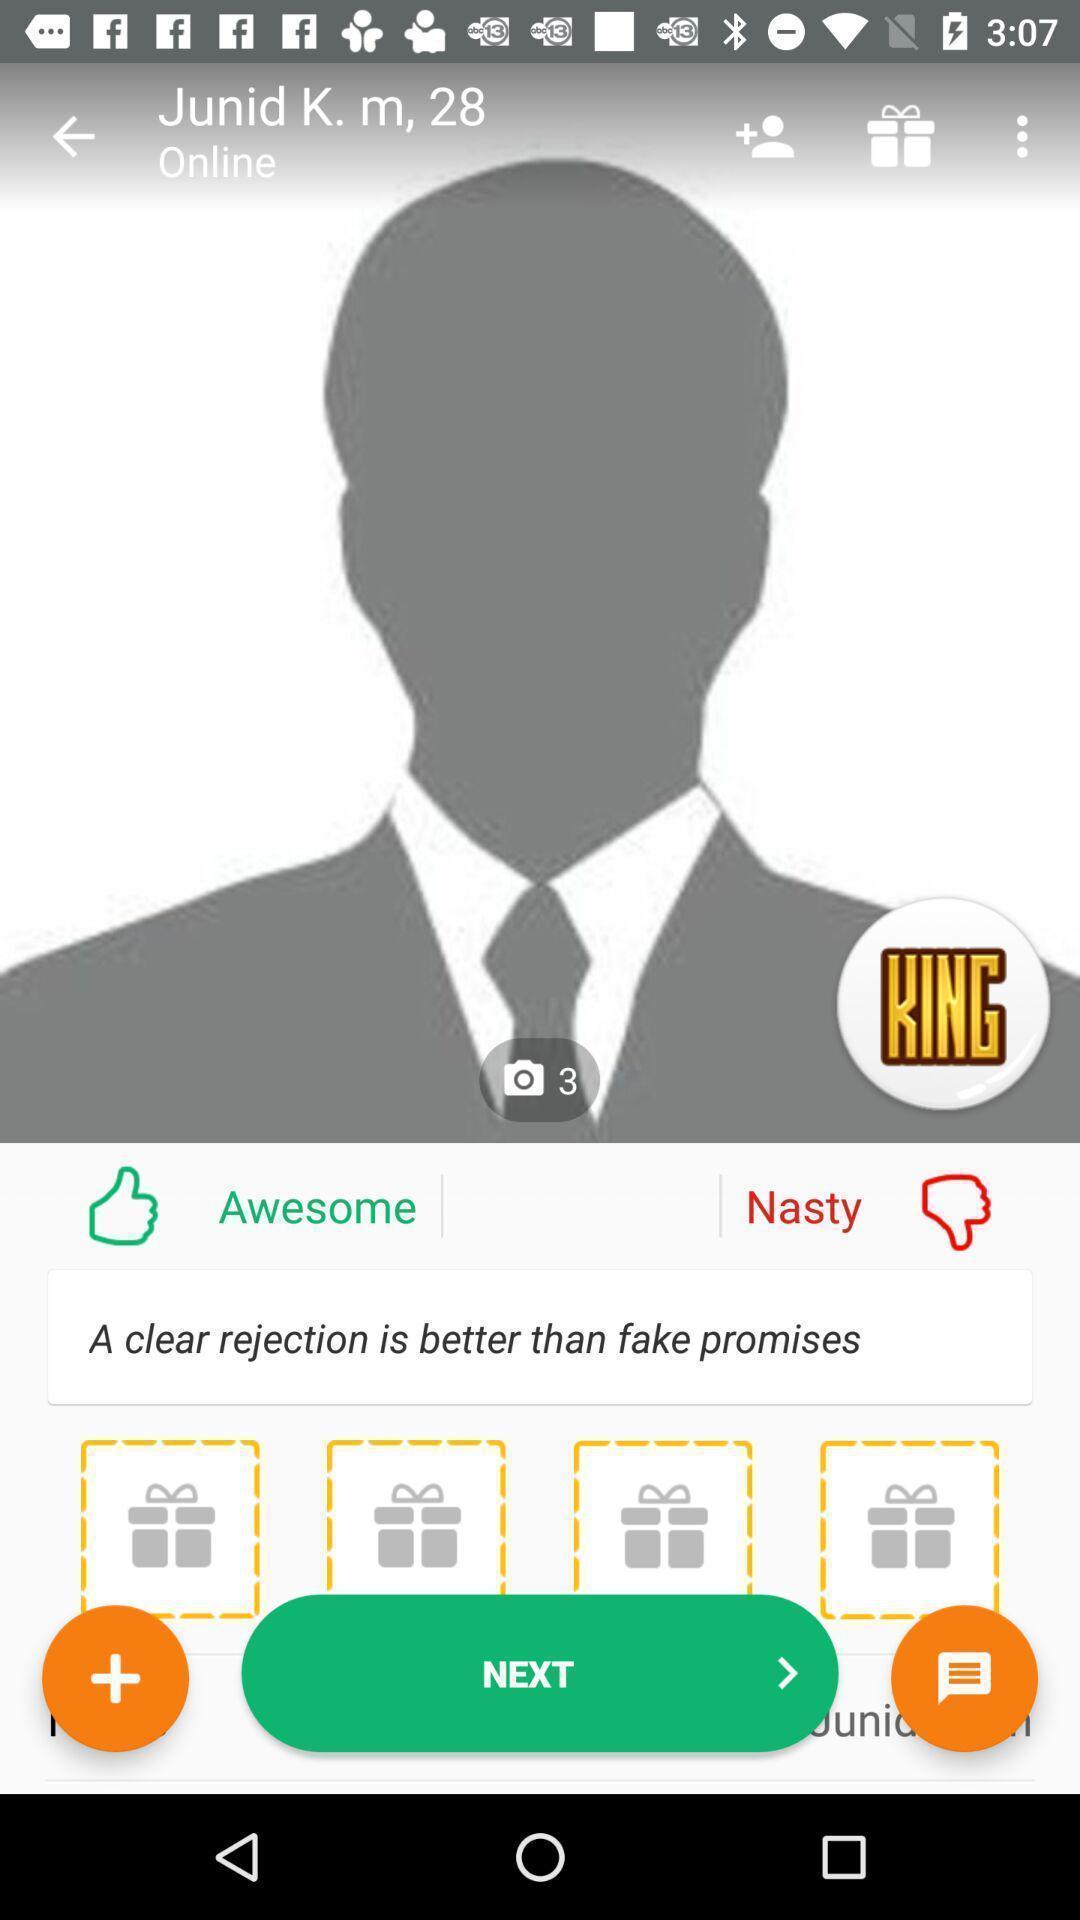Please provide a description for this image. Screen displaying the profile page. 